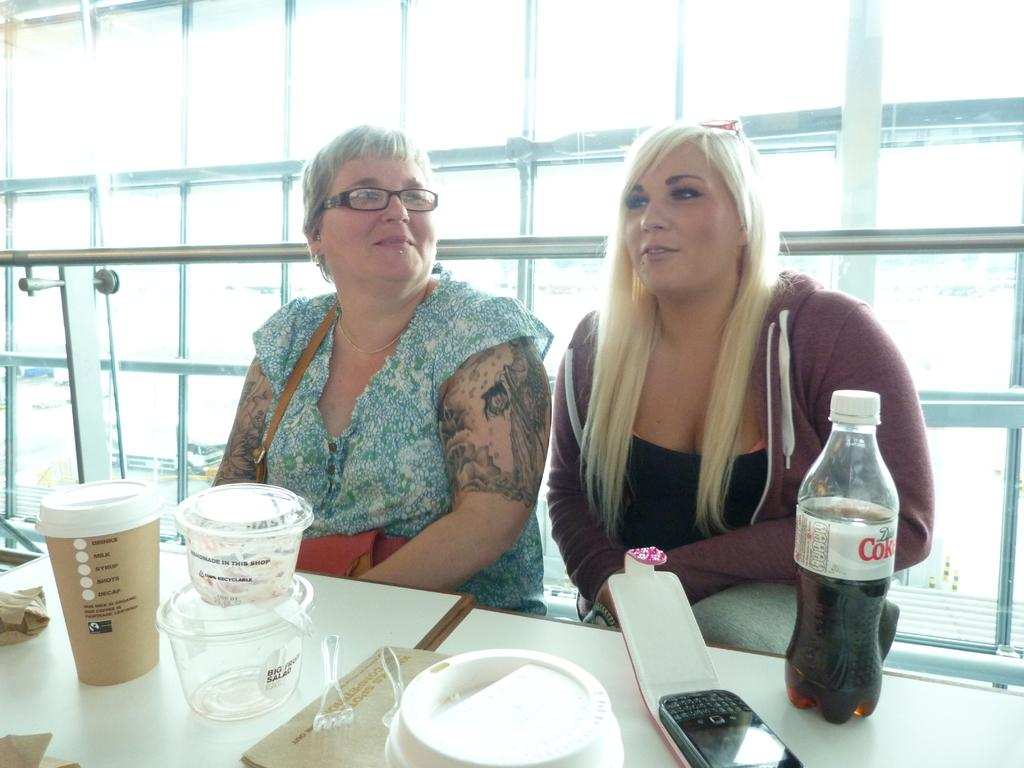How many women are sitting in the image? There are two women sitting on chairs in the image. What is on the table in the image? A coke bottle, a mobile phone, boxes, spoons, and a tumbler are present on the table in the image. What is the background of the image? The background of the image looks like a glass. What type of metal is used to make the thread visible in the image? There is no thread visible in the image, so it is not possible to determine the type of metal used to make it. 